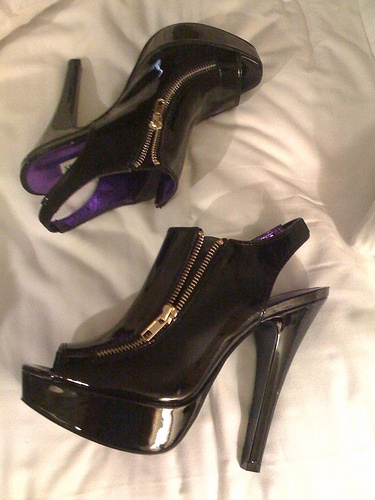Describe the objects in this image and their specific colors. I can see a bed in black, ivory, and tan tones in this image. 